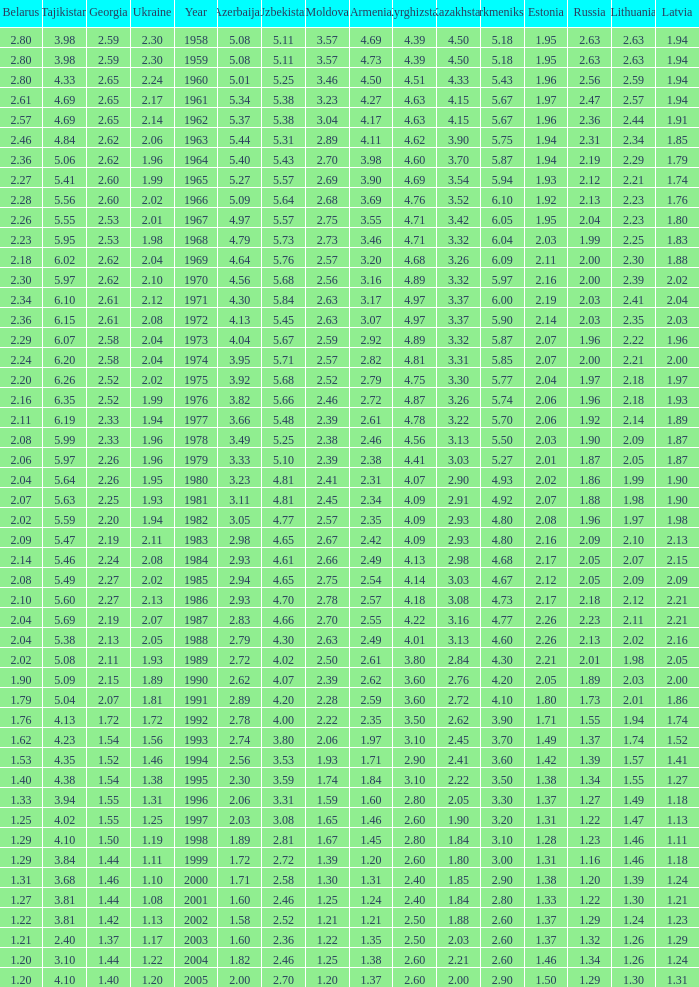Tell me the lowest kazakhstan for kyrghizstan of 4.62 and belarus less than 2.46 None. 